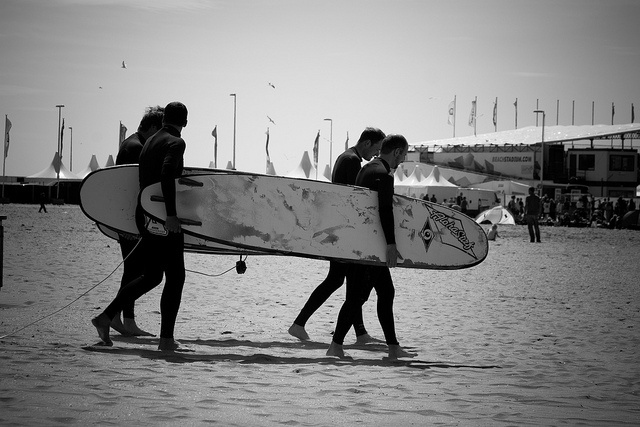Describe the objects in this image and their specific colors. I can see surfboard in gray, dimgray, black, and lightgray tones, people in gray, black, darkgray, and lightgray tones, people in gray, black, darkgray, and lightgray tones, surfboard in gray, black, darkgray, and lightgray tones, and people in gray, black, darkgray, and lightgray tones in this image. 